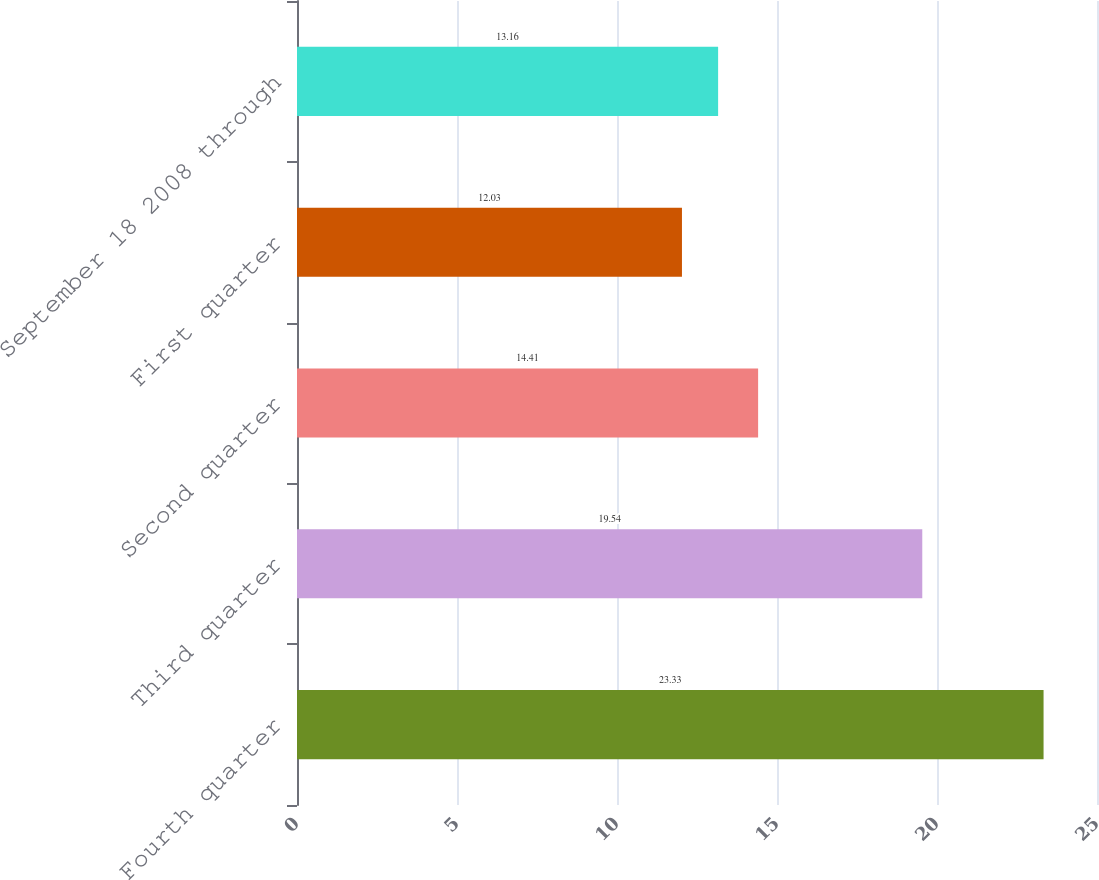Convert chart. <chart><loc_0><loc_0><loc_500><loc_500><bar_chart><fcel>Fourth quarter<fcel>Third quarter<fcel>Second quarter<fcel>First quarter<fcel>September 18 2008 through<nl><fcel>23.33<fcel>19.54<fcel>14.41<fcel>12.03<fcel>13.16<nl></chart> 